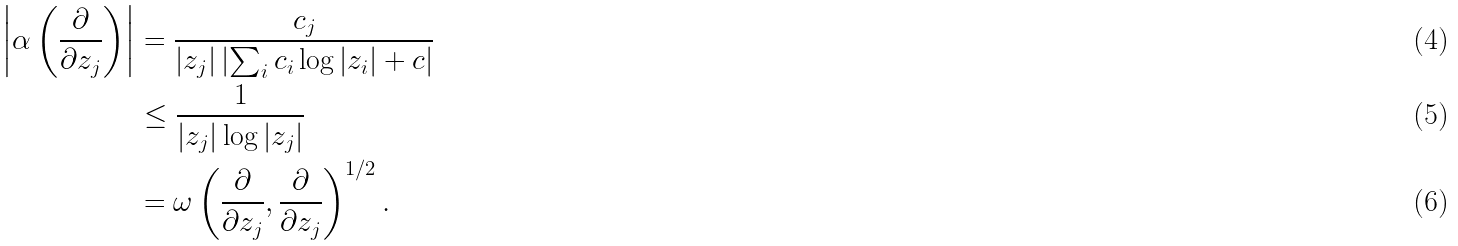Convert formula to latex. <formula><loc_0><loc_0><loc_500><loc_500>\left | \alpha \left ( \frac { \partial } { \partial z _ { j } } \right ) \right | & = \frac { c _ { j } } { | z _ { j } | \left | \sum _ { i } c _ { i } \log | z _ { i } | + c \right | } \\ & \leq \frac { 1 } { | z _ { j } | \log | z _ { j } | } \\ & = \omega \left ( \frac { \partial } { \partial z _ { j } } , \frac { \partial } { \partial z _ { j } } \right ) ^ { 1 / 2 } .</formula> 